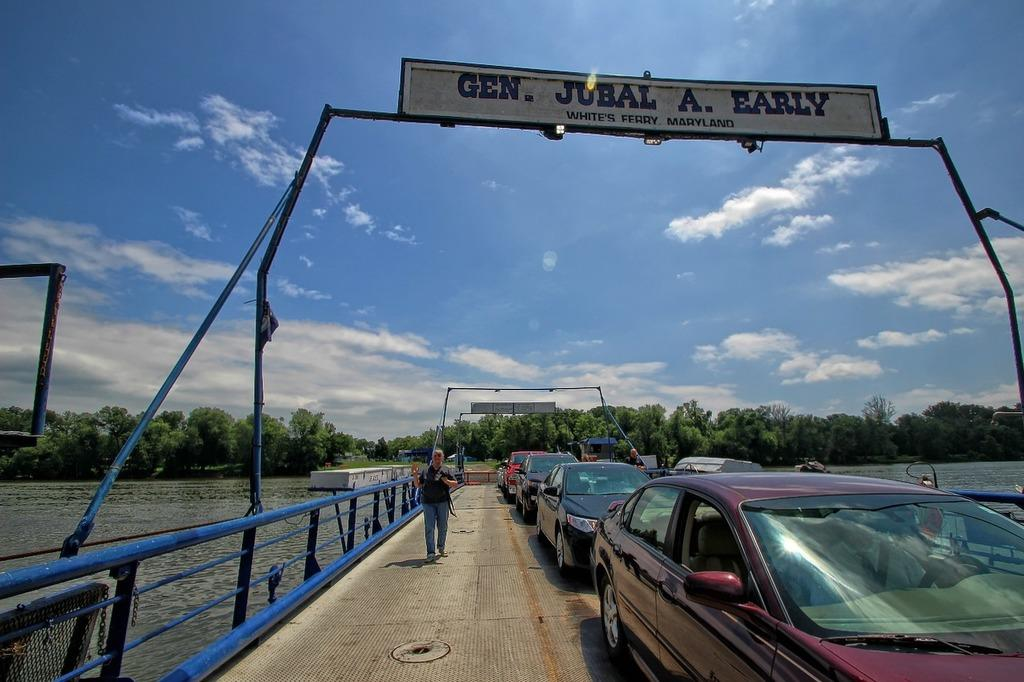<image>
Describe the image concisely. A bridge with a person walking on the left; the word Gen is visible on the top left. 